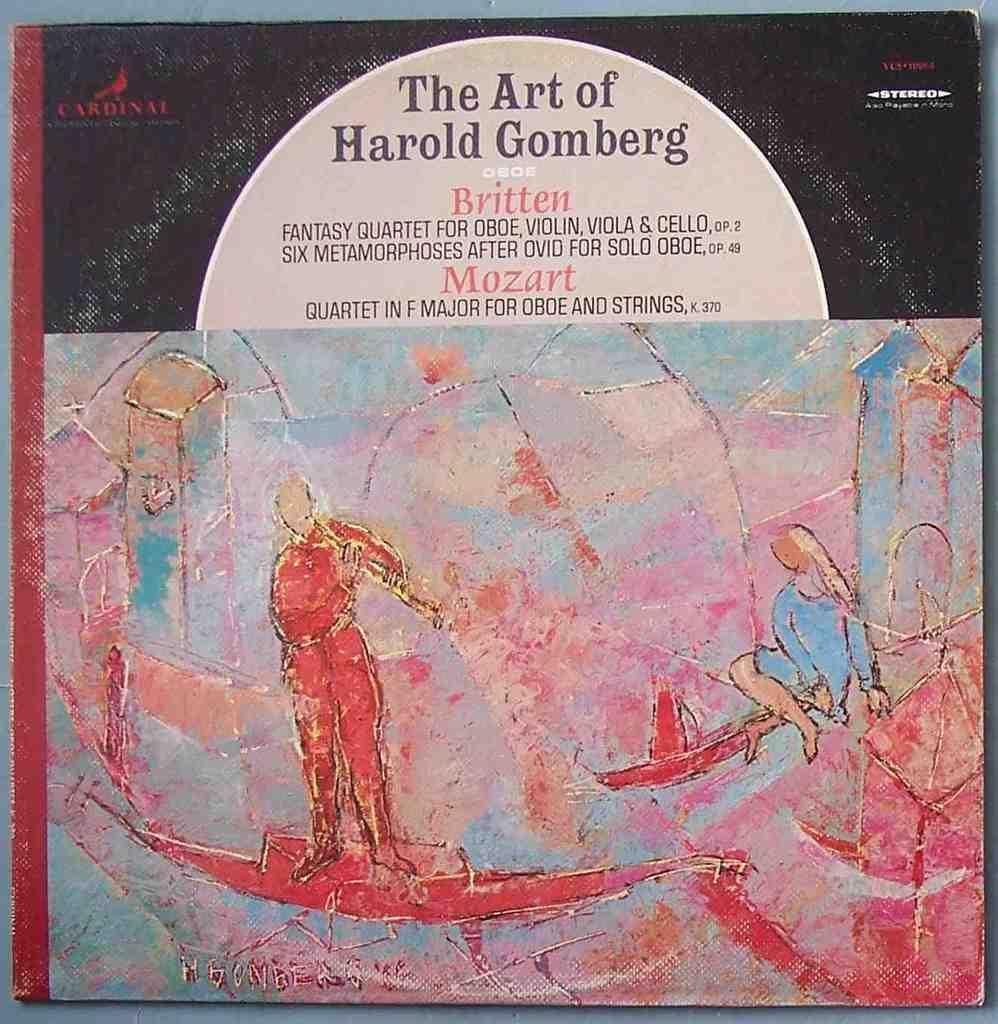Please provide a concise description of this image. We can see book,on this book we can see painting of people and text. 